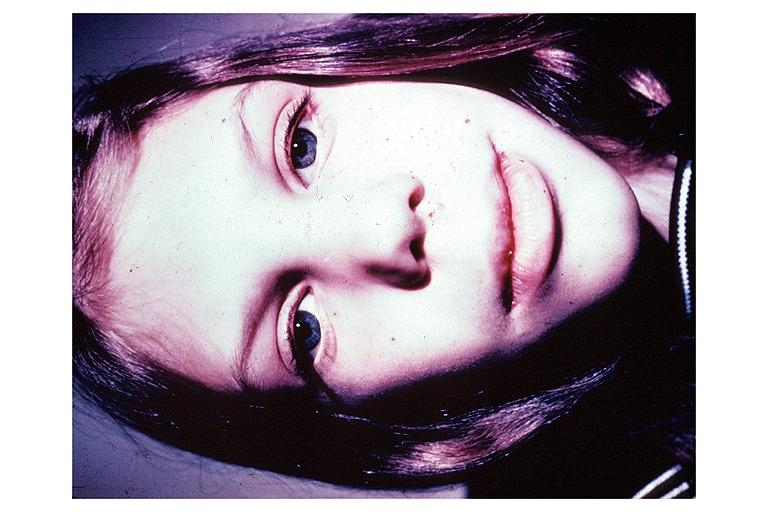s close-up excellent example of interosseous muscle atrophy present?
Answer the question using a single word or phrase. No 